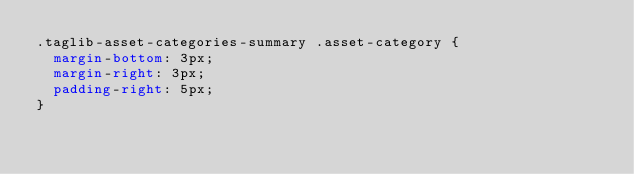<code> <loc_0><loc_0><loc_500><loc_500><_CSS_>.taglib-asset-categories-summary .asset-category {
	margin-bottom: 3px;
	margin-right: 3px;
	padding-right: 5px;
}</code> 